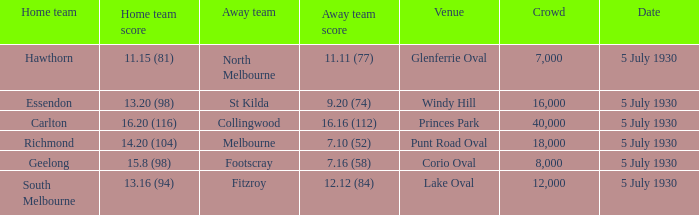What day does the team play at punt road oval? 5 July 1930. 